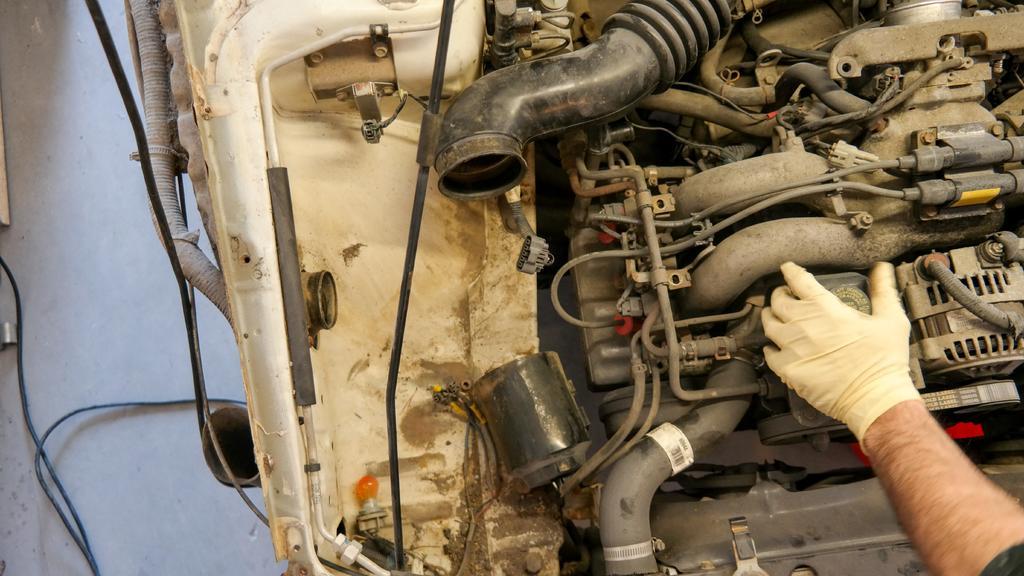Can you describe this image briefly? It is the picture of an engine of a vehicle. There is a hand of a man on one of the part of engine,there are some wires beside the engine. 